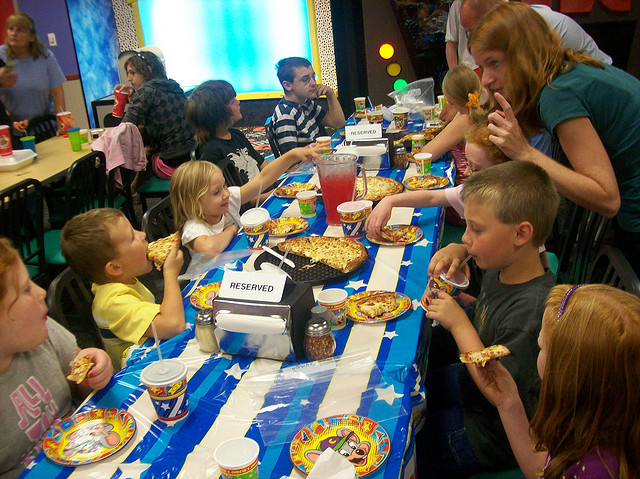<image>What snake are the children eating? There is no snake the children are eating. It can be seen they are eating pizza. What snake are the children eating? It is not clear what snake the children are eating. It can be seen that they are eating pizza, but there is no snake in the image. 